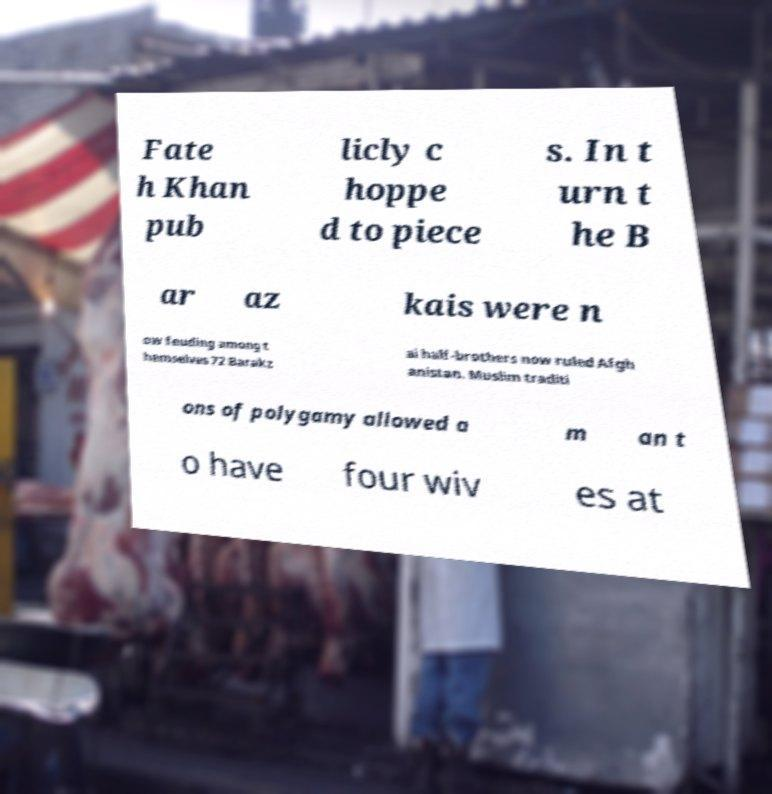There's text embedded in this image that I need extracted. Can you transcribe it verbatim? Fate h Khan pub licly c hoppe d to piece s. In t urn t he B ar az kais were n ow feuding among t hemselves 72 Barakz ai half-brothers now ruled Afgh anistan. Muslim traditi ons of polygamy allowed a m an t o have four wiv es at 